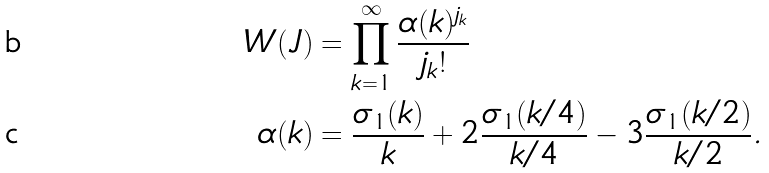<formula> <loc_0><loc_0><loc_500><loc_500>W ( J ) & = \prod _ { k = 1 } ^ { \infty } \frac { \alpha ( k ) ^ { j _ { k } } } { j _ { k } ! } \\ \alpha ( k ) & = \frac { \sigma _ { 1 } ( k ) } { k } + 2 \frac { \sigma _ { 1 } ( k / 4 ) } { k / 4 } - 3 \frac { \sigma _ { 1 } ( k / 2 ) } { k / 2 } .</formula> 